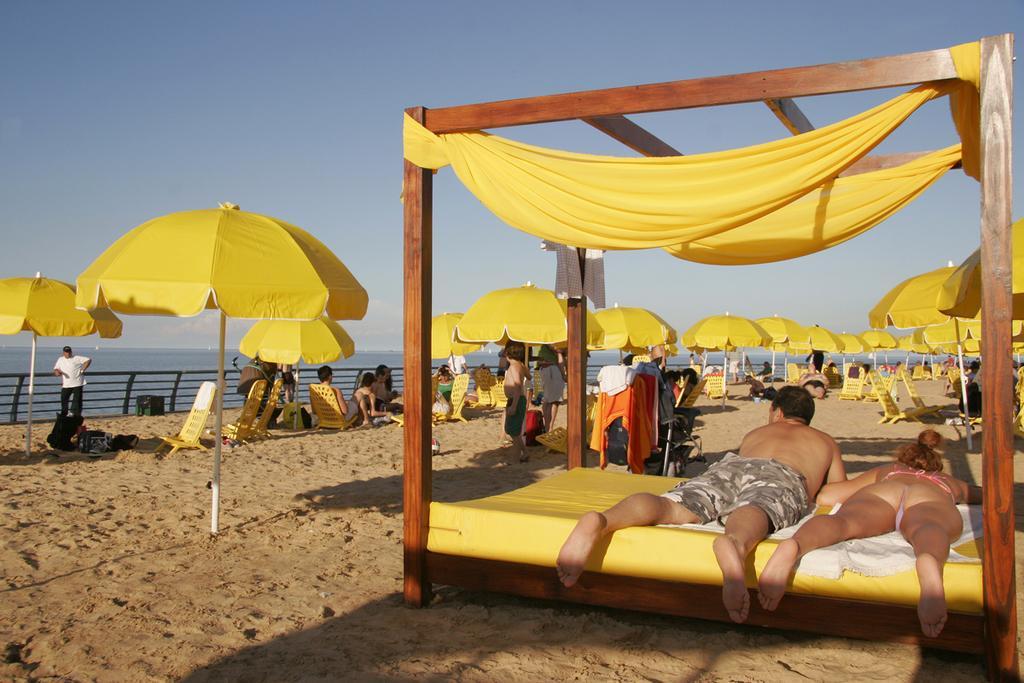Can you describe this image briefly? In the foreground of this image, there is a man and a woman lying on a bed and we can also see yellow color curtains to it. In the background, there are umbrellas, chairs, few people standing and sitting and also there is sand at the bottom. In the background, there is water, railing and the sky. 